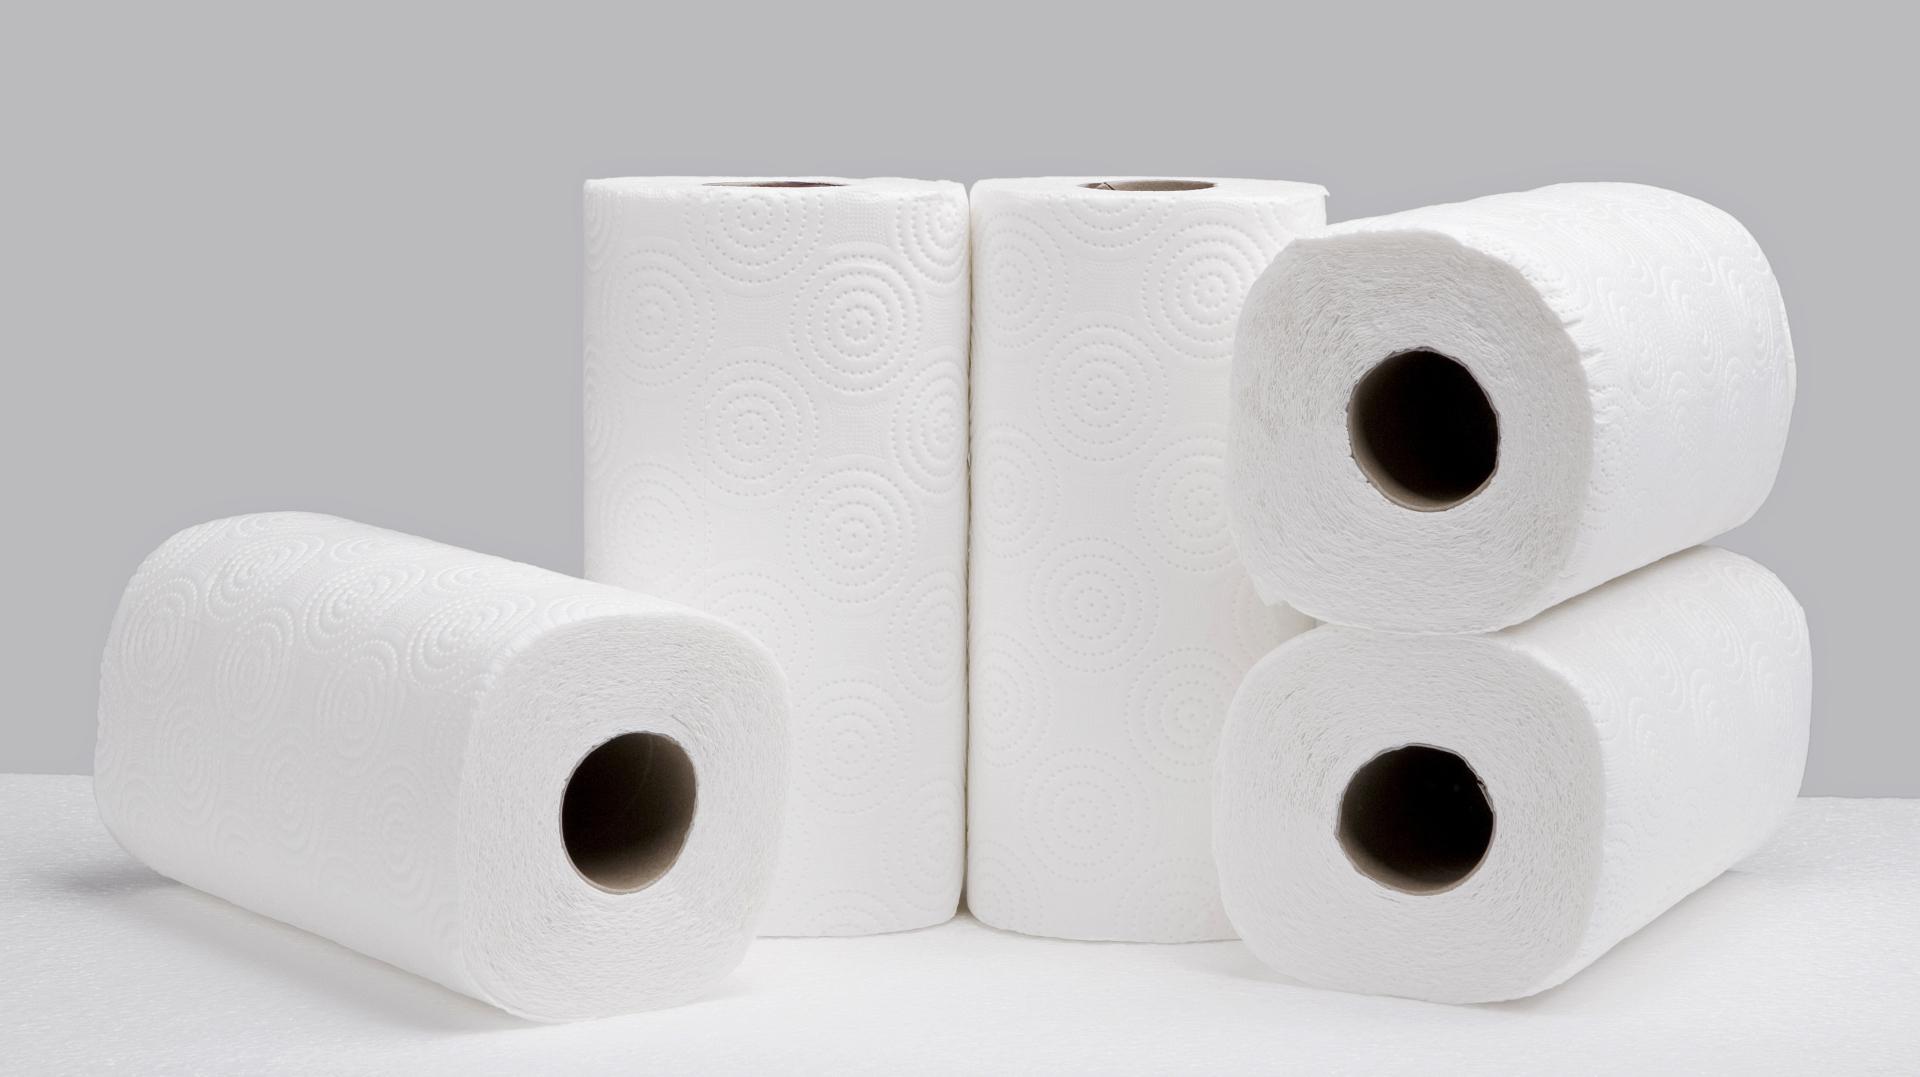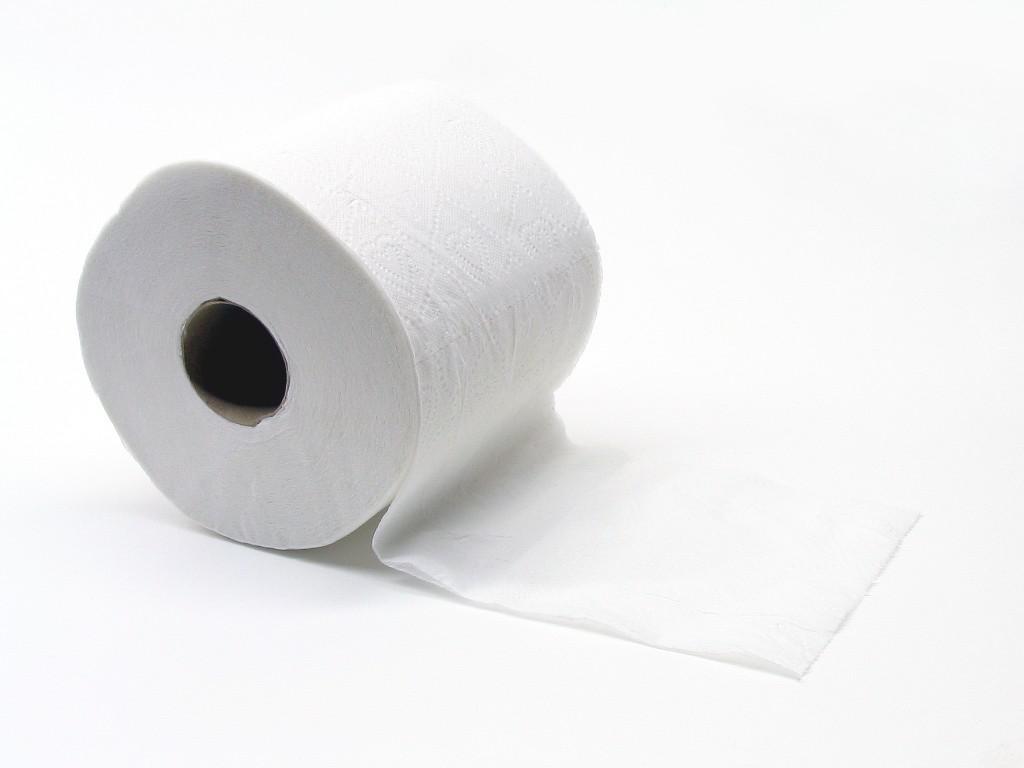The first image is the image on the left, the second image is the image on the right. Considering the images on both sides, is "The left image contains at least five paper rolls." valid? Answer yes or no. Yes. 